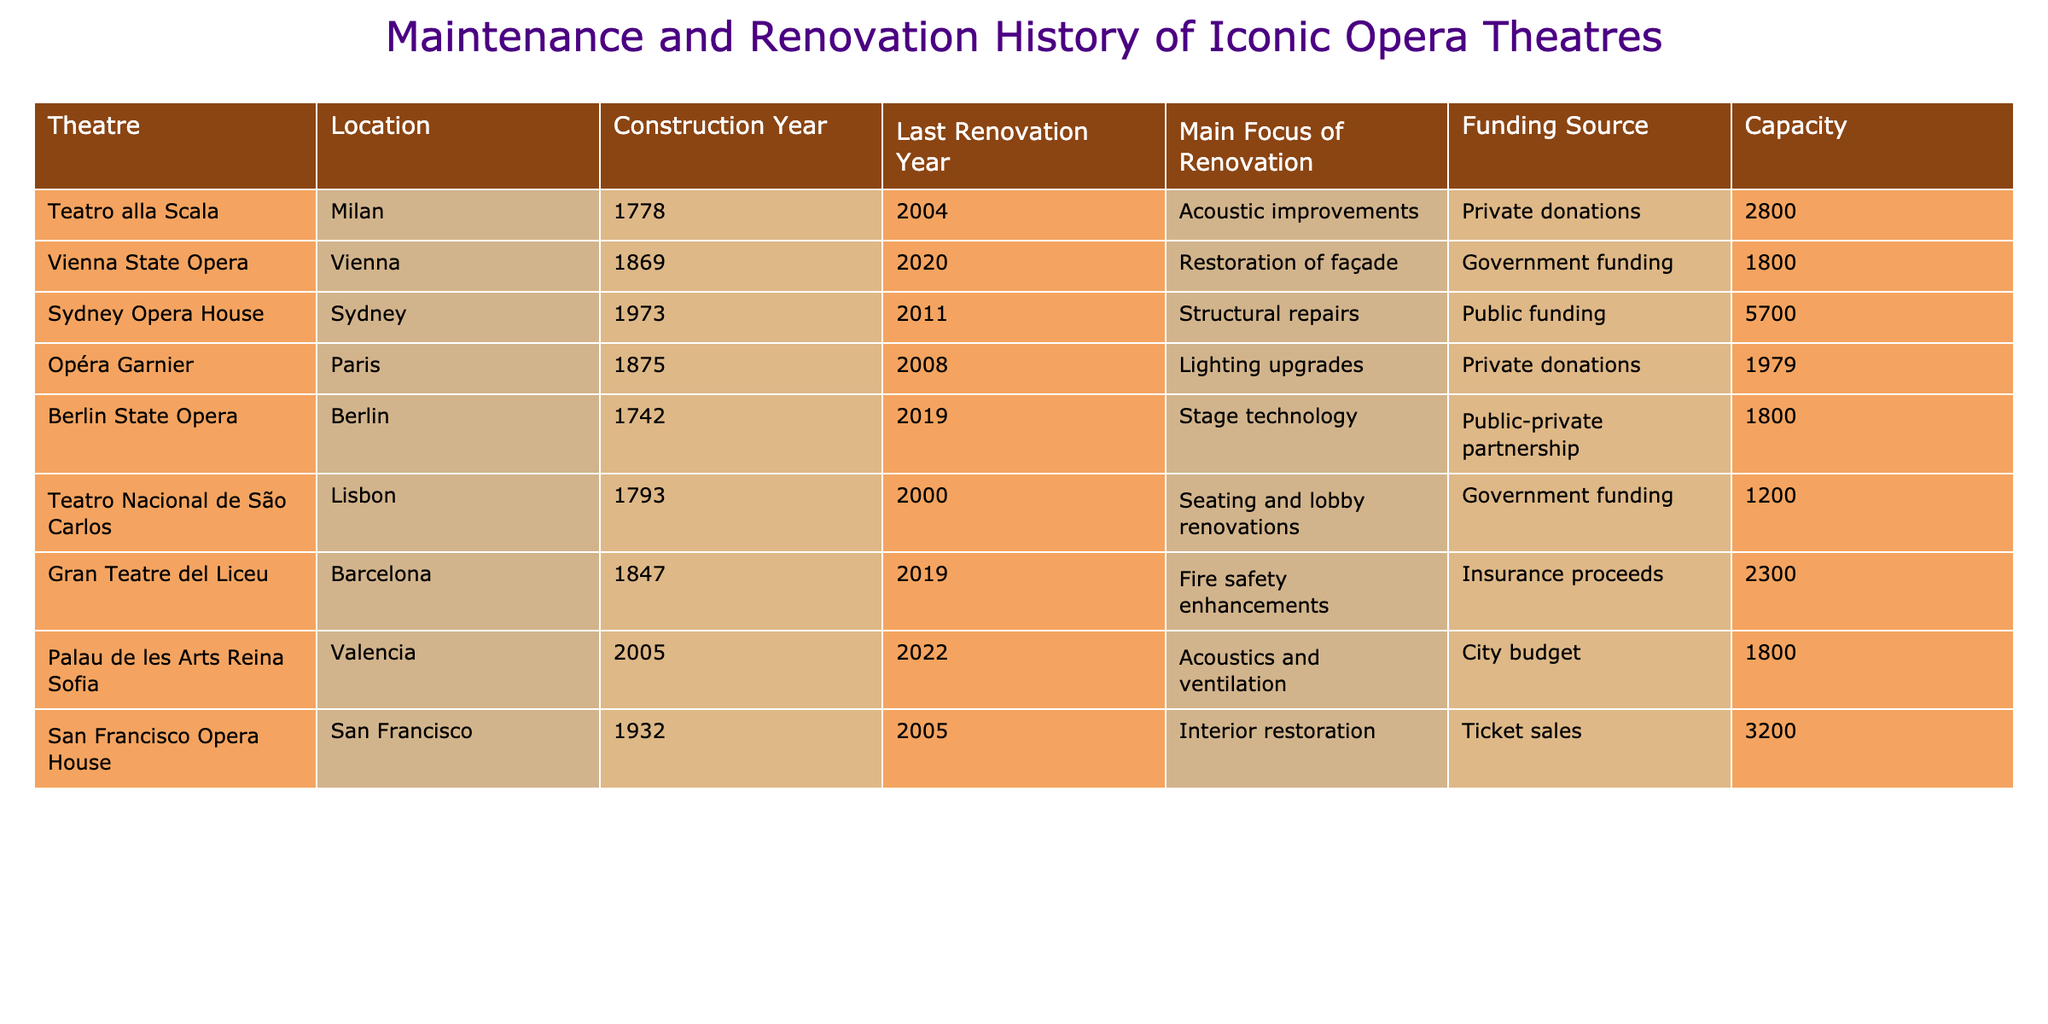What is the construction year of the Vienna State Opera? The table shows that the Vienna State Opera was constructed in 1869.
Answer: 1869 Which theatre underwent the last renovation in 2020? According to the table, the Vienna State Opera is noted for its last renovation in the year 2020.
Answer: Vienna State Opera How many theatres had their last renovation completed after 2000? By scanning the 'Last Renovation Year' column, we identify the years 2004, 2008, 2011, 2019, and 2020, indicating a total of 5 theatres (Teatro alla Scala, Opéra Garnier, Sydney Opera House, Berlin State Opera, and Vienna State Opera) had renovations completed after 2000.
Answer: 5 Which funding source was used for the renovations at the Berlin State Opera? The table specifies that the Berlin State Opera's renovations were funded through a public-private partnership.
Answer: Public-private partnership What is the total seating capacity of the theatres renovated after the year 2000? The theatres that underwent renovations after 2000 are Teatro alla Scala (2800), Sydney Opera House (5700), Palau de les Arts Reina Sofia (1800), and Berlin State Opera (1800). Adding these together, the total capacity is 2800 + 5700 + 1800 + 1800 = 12100.
Answer: 12100 Did the Sydney Opera House focus on acoustic improvements during its last renovation? The table indicates that the Sydney Opera House had a focus on structural repairs during its last renovation, not acoustic improvements.
Answer: No Which theatre has the largest capacity? By examining the 'Capacity' column, the Sydney Opera House has the largest capacity listed, which is 5700 seats.
Answer: Sydney Opera House How many theatres used private donations as a funding source, and which are they? Looking at the funding sources, we find two theatres that used private donations for their renovations: Teatro alla Scala and Opéra Garnier. Therefore, the total number is 2.
Answer: 2 What is the average seating capacity of theatres that underwent renovations focused on lighting upgrades? The only theatre with a focus on lighting upgrades is Opéra Garnier, which has a capacity of 1979. Since there is only one theatre, the average is the same as the individual capacity, which is 1979.
Answer: 1979 